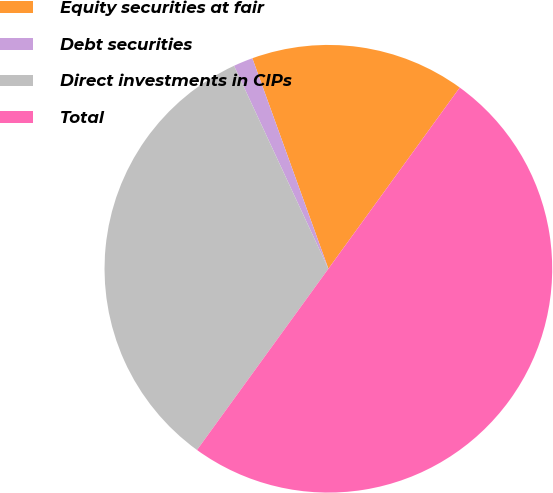Convert chart to OTSL. <chart><loc_0><loc_0><loc_500><loc_500><pie_chart><fcel>Equity securities at fair<fcel>Debt securities<fcel>Direct investments in CIPs<fcel>Total<nl><fcel>15.5%<fcel>1.41%<fcel>33.09%<fcel>50.0%<nl></chart> 